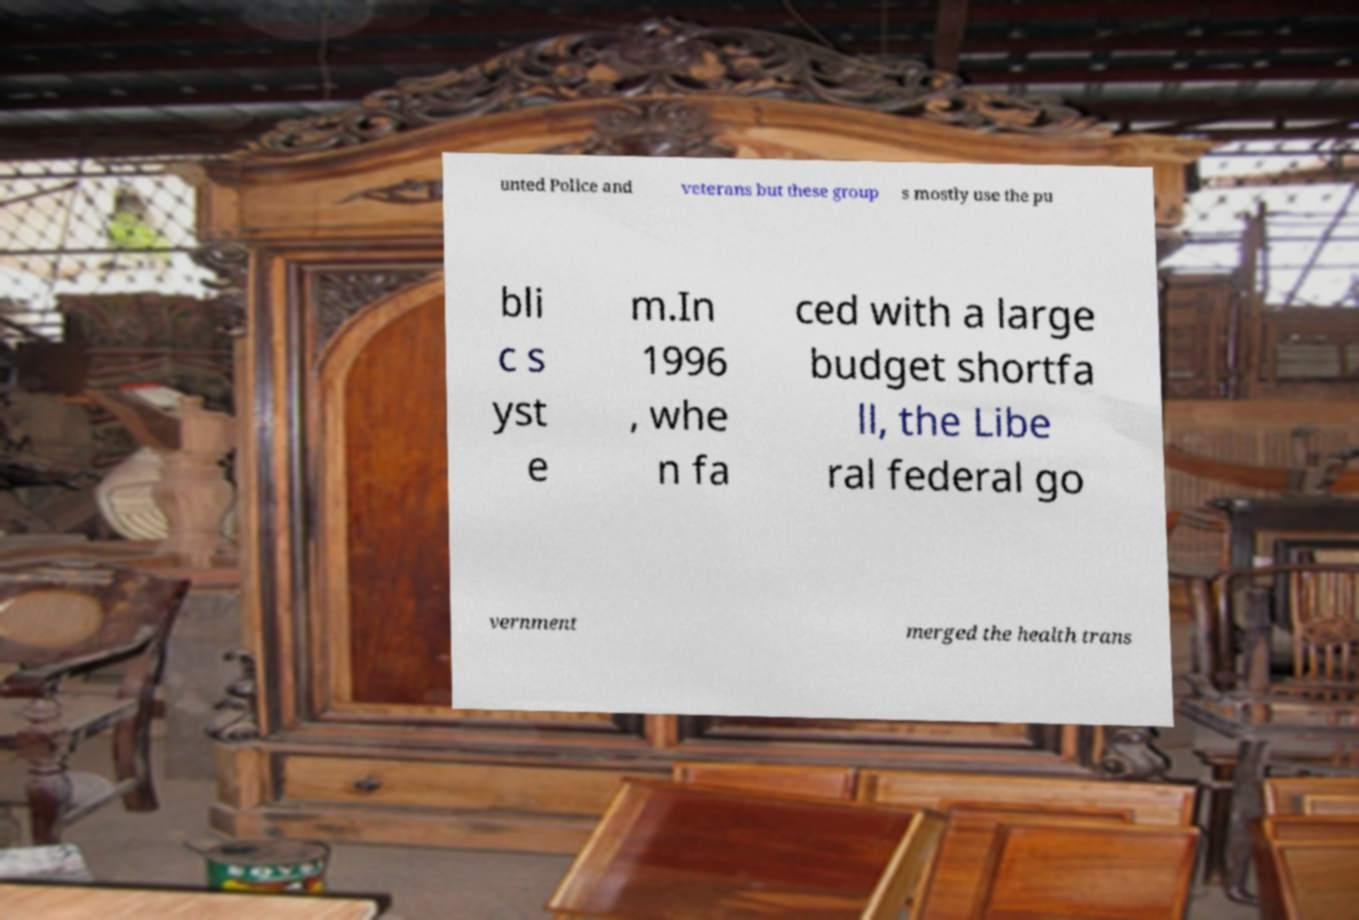Can you read and provide the text displayed in the image?This photo seems to have some interesting text. Can you extract and type it out for me? unted Police and veterans but these group s mostly use the pu bli c s yst e m.In 1996 , whe n fa ced with a large budget shortfa ll, the Libe ral federal go vernment merged the health trans 